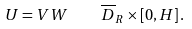Convert formula to latex. <formula><loc_0><loc_0><loc_500><loc_500>U = V W \quad \overline { D } _ { R } \times [ 0 , H ] \, .</formula> 